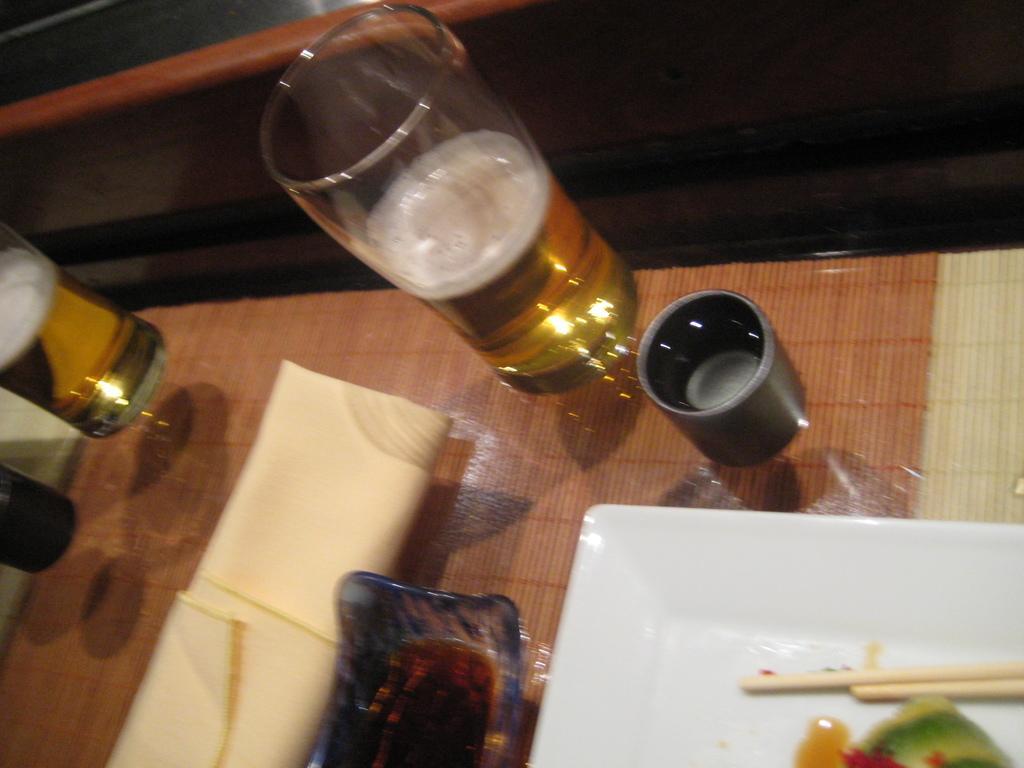Please provide a concise description of this image. In this picture there are two glasses, bowl, food in the plate, two chopsticks in the plate. There is a table and a cream cloth on the table. 